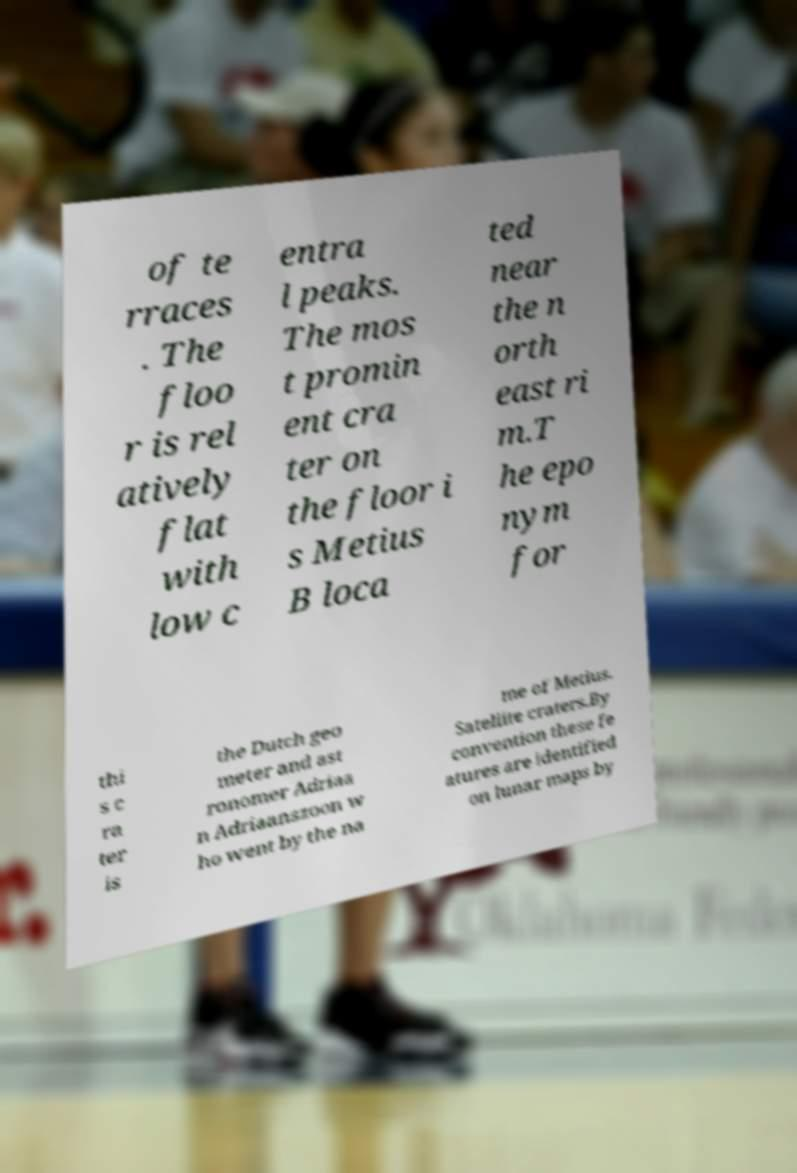Could you extract and type out the text from this image? of te rraces . The floo r is rel atively flat with low c entra l peaks. The mos t promin ent cra ter on the floor i s Metius B loca ted near the n orth east ri m.T he epo nym for thi s c ra ter is the Dutch geo meter and ast ronomer Adriaa n Adriaanszoon w ho went by the na me of Metius. Satellite craters.By convention these fe atures are identified on lunar maps by 